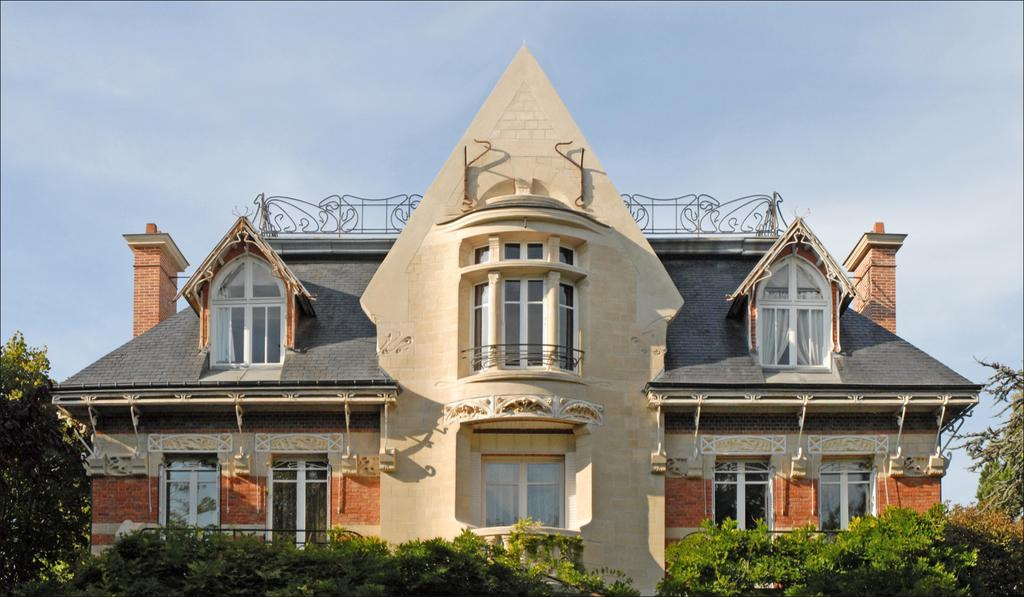What type of structure is present in the image? There is a building in the image. What feature can be seen on the building? The building has windows. What type of natural elements are visible in the image? There are trees visible in the image. How would you describe the sky in the image? The sky is cloudy and pale blue in the image. Where is the jar of pickles located in the image? There is no jar of pickles present in the image. What type of office equipment can be seen in the image? The image does not show any office equipment, as it primarily features a building, trees, and a cloudy sky. 